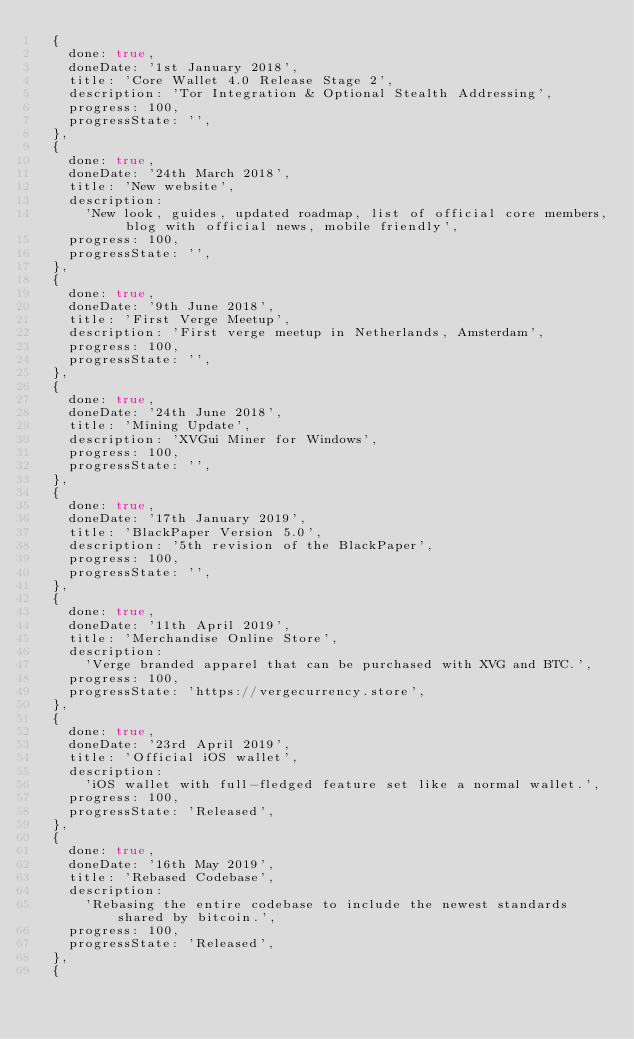Convert code to text. <code><loc_0><loc_0><loc_500><loc_500><_JavaScript_>  {
    done: true,
    doneDate: '1st January 2018',
    title: 'Core Wallet 4.0 Release Stage 2',
    description: 'Tor Integration & Optional Stealth Addressing',
    progress: 100,
    progressState: '',
  },
  {
    done: true,
    doneDate: '24th March 2018',
    title: 'New website',
    description:
      'New look, guides, updated roadmap, list of official core members, blog with official news, mobile friendly',
    progress: 100,
    progressState: '',
  },
  {
    done: true,
    doneDate: '9th June 2018',
    title: 'First Verge Meetup',
    description: 'First verge meetup in Netherlands, Amsterdam',
    progress: 100,
    progressState: '',
  },
  {
    done: true,
    doneDate: '24th June 2018',
    title: 'Mining Update',
    description: 'XVGui Miner for Windows',
    progress: 100,
    progressState: '',
  },
  {
    done: true,
    doneDate: '17th January 2019',
    title: 'BlackPaper Version 5.0',
    description: '5th revision of the BlackPaper',
    progress: 100,
    progressState: '',
  },
  {
    done: true,
    doneDate: '11th April 2019',
    title: 'Merchandise Online Store',
    description:
      'Verge branded apparel that can be purchased with XVG and BTC.',
    progress: 100,
    progressState: 'https://vergecurrency.store',
  },
  {
    done: true,
    doneDate: '23rd April 2019',
    title: 'Official iOS wallet',
    description:
      'iOS wallet with full-fledged feature set like a normal wallet.',
    progress: 100,
    progressState: 'Released',
  },
  {
    done: true,
    doneDate: '16th May 2019',
    title: 'Rebased Codebase',
    description:
      'Rebasing the entire codebase to include the newest standards shared by bitcoin.',
    progress: 100,
    progressState: 'Released',
  },
  {</code> 